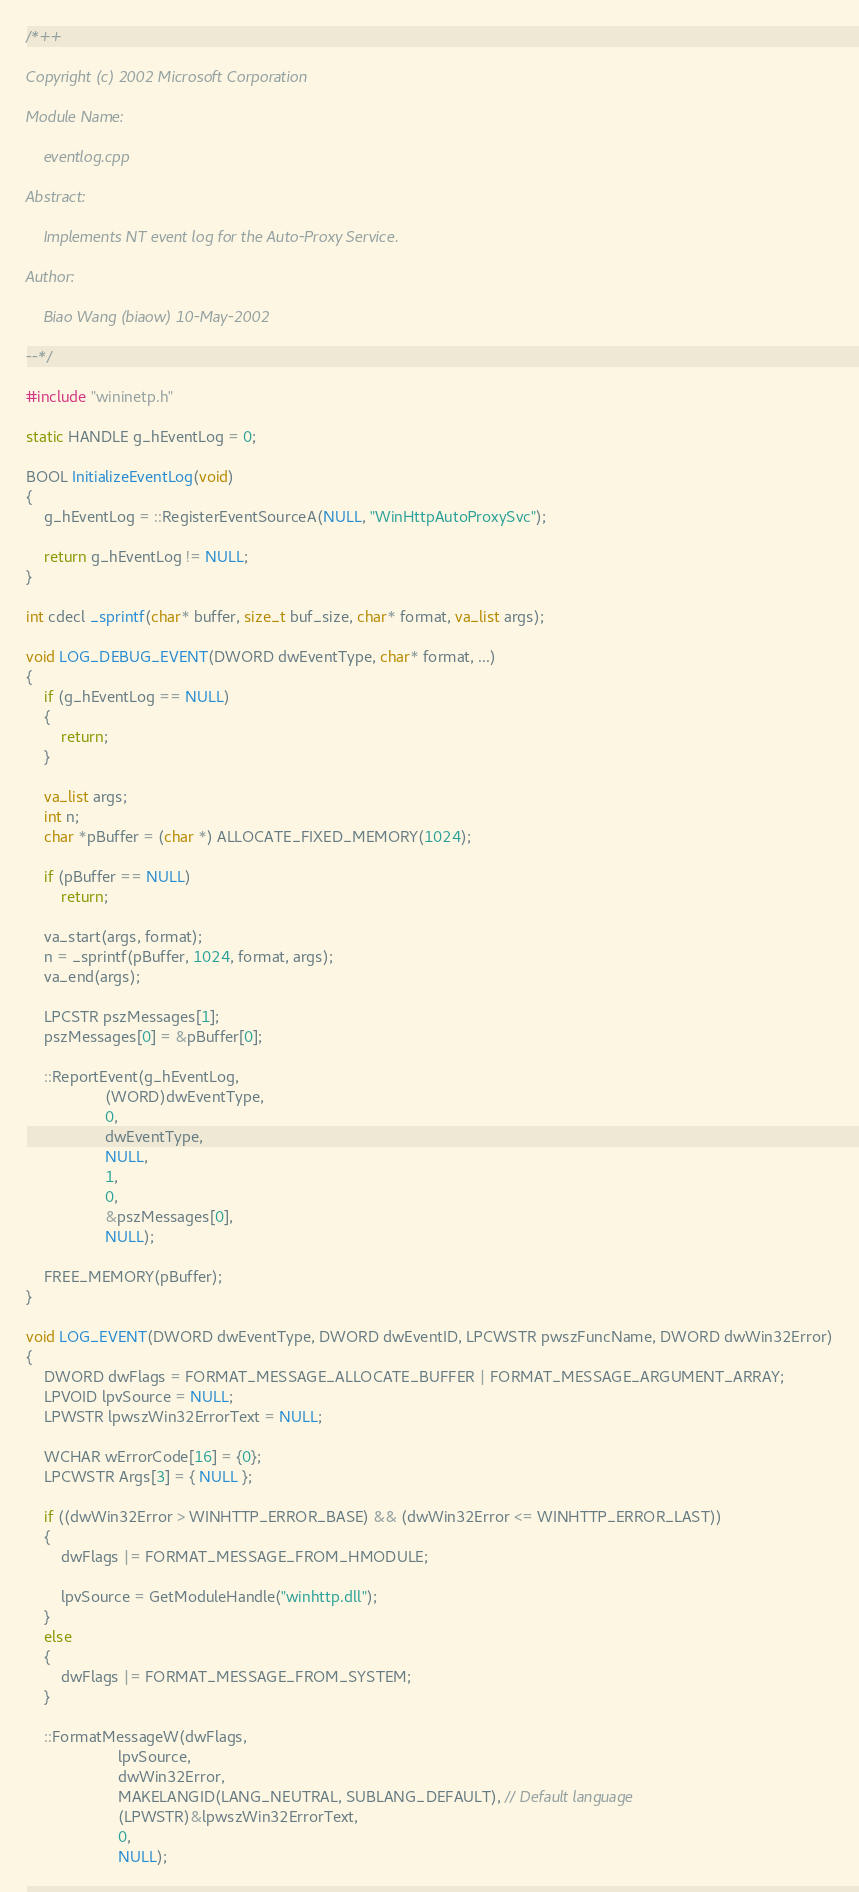Convert code to text. <code><loc_0><loc_0><loc_500><loc_500><_C++_>/*++

Copyright (c) 2002 Microsoft Corporation

Module Name:

    eventlog.cpp

Abstract:

    Implements NT event log for the Auto-Proxy Service.

Author:

    Biao Wang (biaow) 10-May-2002

--*/

#include "wininetp.h"

static HANDLE g_hEventLog = 0;

BOOL InitializeEventLog(void)
{
    g_hEventLog = ::RegisterEventSourceA(NULL, "WinHttpAutoProxySvc");

    return g_hEventLog != NULL;
}

int cdecl _sprintf(char* buffer, size_t buf_size, char* format, va_list args);

void LOG_DEBUG_EVENT(DWORD dwEventType, char* format, ...)
{
    if (g_hEventLog == NULL)
    {
        return;
    }

    va_list args;
    int n;
    char *pBuffer = (char *) ALLOCATE_FIXED_MEMORY(1024);

    if (pBuffer == NULL)
        return;

    va_start(args, format);
    n = _sprintf(pBuffer, 1024, format, args);    
    va_end(args);
    
    LPCSTR pszMessages[1];
    pszMessages[0] = &pBuffer[0];

    ::ReportEvent(g_hEventLog, 
                  (WORD)dwEventType,
                  0,
                  dwEventType,
                  NULL,
                  1,
                  0,
                  &pszMessages[0],
                  NULL);

    FREE_MEMORY(pBuffer);
}

void LOG_EVENT(DWORD dwEventType, DWORD dwEventID, LPCWSTR pwszFuncName, DWORD dwWin32Error)
{
    DWORD dwFlags = FORMAT_MESSAGE_ALLOCATE_BUFFER | FORMAT_MESSAGE_ARGUMENT_ARRAY;
    LPVOID lpvSource = NULL;
    LPWSTR lpwszWin32ErrorText = NULL;
    
    WCHAR wErrorCode[16] = {0};
    LPCWSTR Args[3] = { NULL };

    if ((dwWin32Error > WINHTTP_ERROR_BASE) && (dwWin32Error <= WINHTTP_ERROR_LAST))
    {
        dwFlags |= FORMAT_MESSAGE_FROM_HMODULE;

        lpvSource = GetModuleHandle("winhttp.dll");
    }
    else
    {
        dwFlags |= FORMAT_MESSAGE_FROM_SYSTEM;
    }

    ::FormatMessageW(dwFlags,
                     lpvSource,
                     dwWin32Error,
                     MAKELANGID(LANG_NEUTRAL, SUBLANG_DEFAULT), // Default language
                     (LPWSTR)&lpwszWin32ErrorText,
                     0,
                     NULL);
</code> 